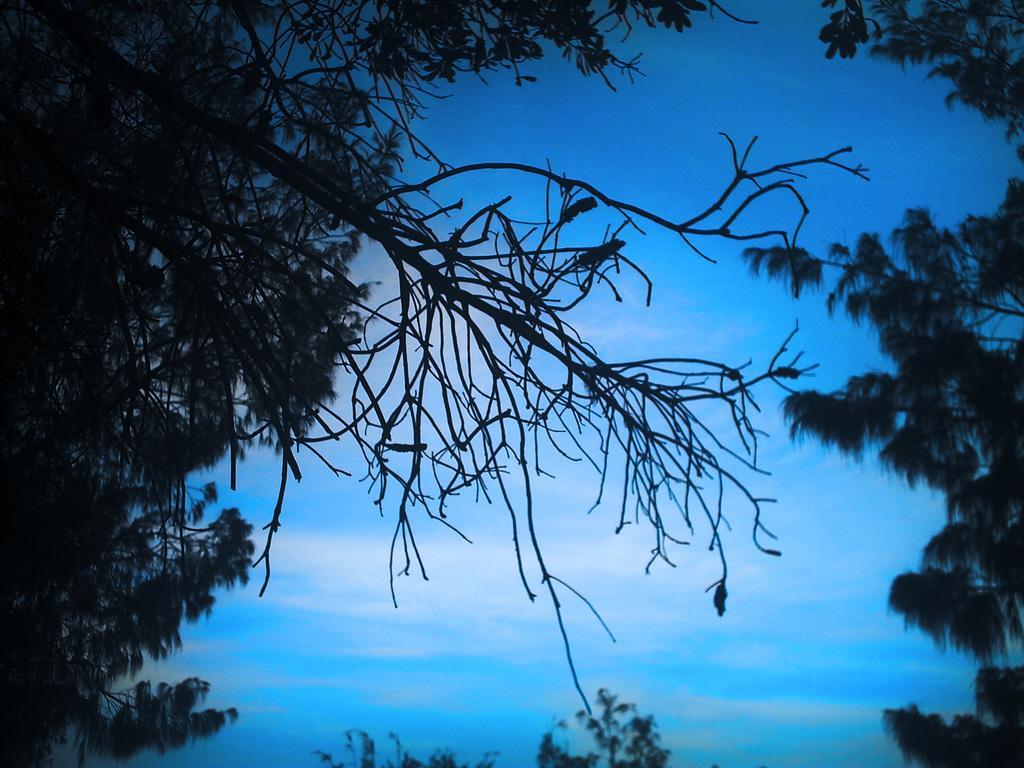Could you give a brief overview of what you see in this image? In the picture I can see trees. In the background I can see the sky. 